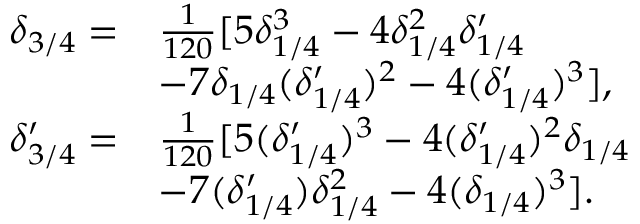<formula> <loc_0><loc_0><loc_500><loc_500>\begin{array} { r l } { \delta _ { 3 / 4 } = } & { \frac { 1 } { 1 2 0 } [ 5 \delta _ { 1 / 4 } ^ { 3 } - 4 \delta _ { 1 / 4 } ^ { 2 } \delta _ { 1 / 4 } ^ { \prime } } \\ & { - 7 \delta _ { 1 / 4 } ( \delta _ { 1 / 4 } ^ { \prime } ) ^ { 2 } - 4 ( \delta _ { 1 / 4 } ^ { \prime } ) ^ { 3 } ] , } \\ { \delta _ { 3 / 4 } ^ { \prime } = } & { \frac { 1 } { 1 2 0 } [ 5 ( \delta _ { 1 / 4 } ^ { \prime } ) ^ { 3 } - 4 ( \delta _ { 1 / 4 } ^ { \prime } ) ^ { 2 } \delta _ { 1 / 4 } } \\ & { - 7 ( \delta _ { 1 / 4 } ^ { \prime } ) \delta _ { 1 / 4 } ^ { 2 } - 4 ( \delta _ { 1 / 4 } ) ^ { 3 } ] . } \end{array}</formula> 